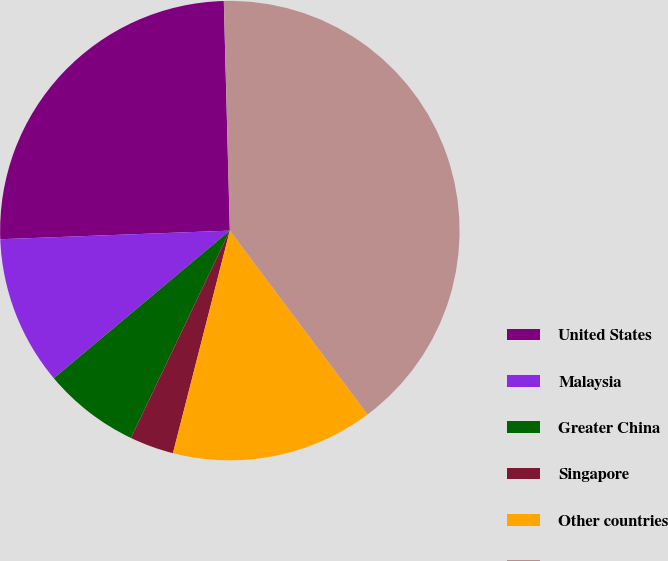<chart> <loc_0><loc_0><loc_500><loc_500><pie_chart><fcel>United States<fcel>Malaysia<fcel>Greater China<fcel>Singapore<fcel>Other countries<fcel>Total long-lived assets<nl><fcel>25.18%<fcel>10.51%<fcel>6.81%<fcel>3.1%<fcel>14.22%<fcel>40.18%<nl></chart> 